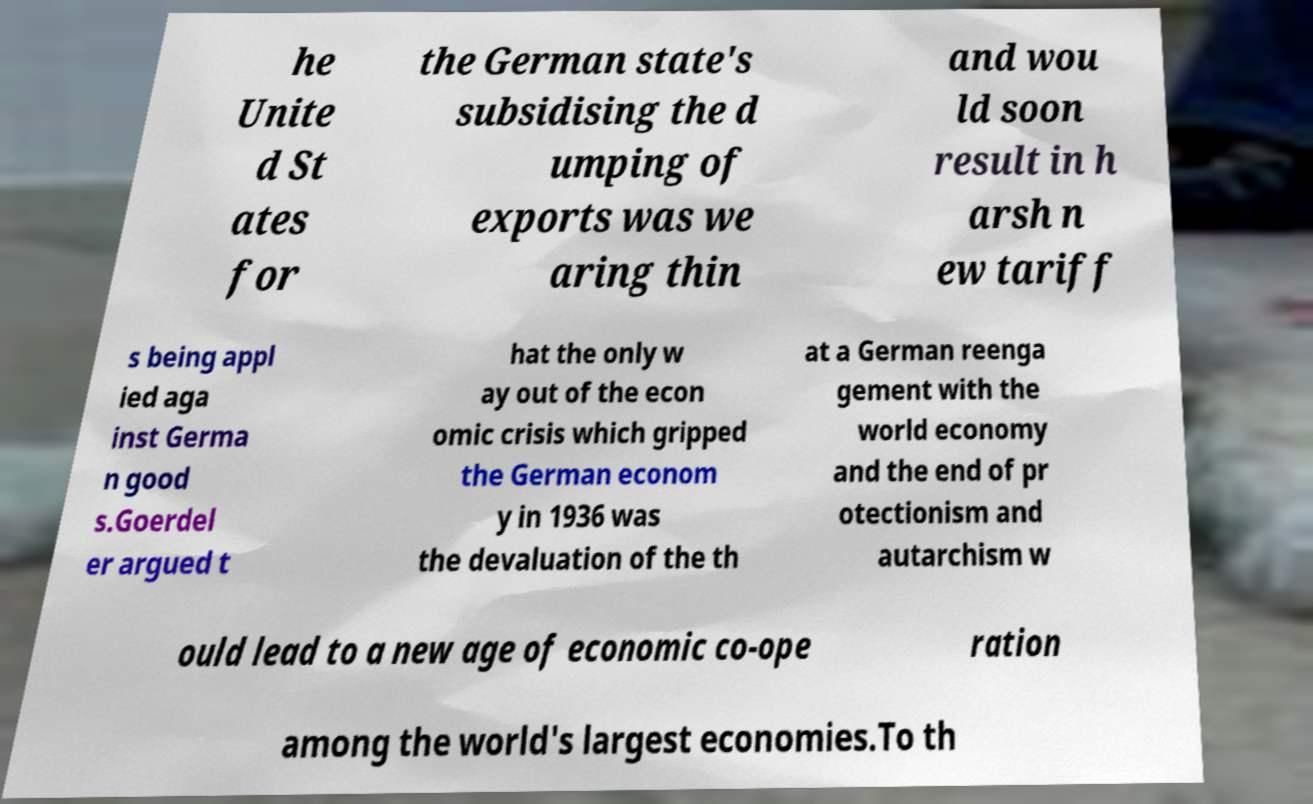I need the written content from this picture converted into text. Can you do that? he Unite d St ates for the German state's subsidising the d umping of exports was we aring thin and wou ld soon result in h arsh n ew tariff s being appl ied aga inst Germa n good s.Goerdel er argued t hat the only w ay out of the econ omic crisis which gripped the German econom y in 1936 was the devaluation of the th at a German reenga gement with the world economy and the end of pr otectionism and autarchism w ould lead to a new age of economic co-ope ration among the world's largest economies.To th 